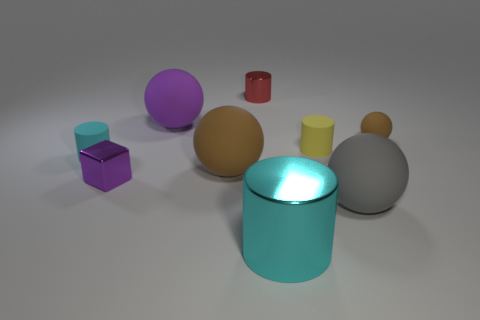Add 1 red metal cylinders. How many objects exist? 10 Subtract all balls. How many objects are left? 5 Subtract all big brown objects. Subtract all big objects. How many objects are left? 4 Add 1 rubber balls. How many rubber balls are left? 5 Add 6 cyan cylinders. How many cyan cylinders exist? 8 Subtract 0 red cubes. How many objects are left? 9 